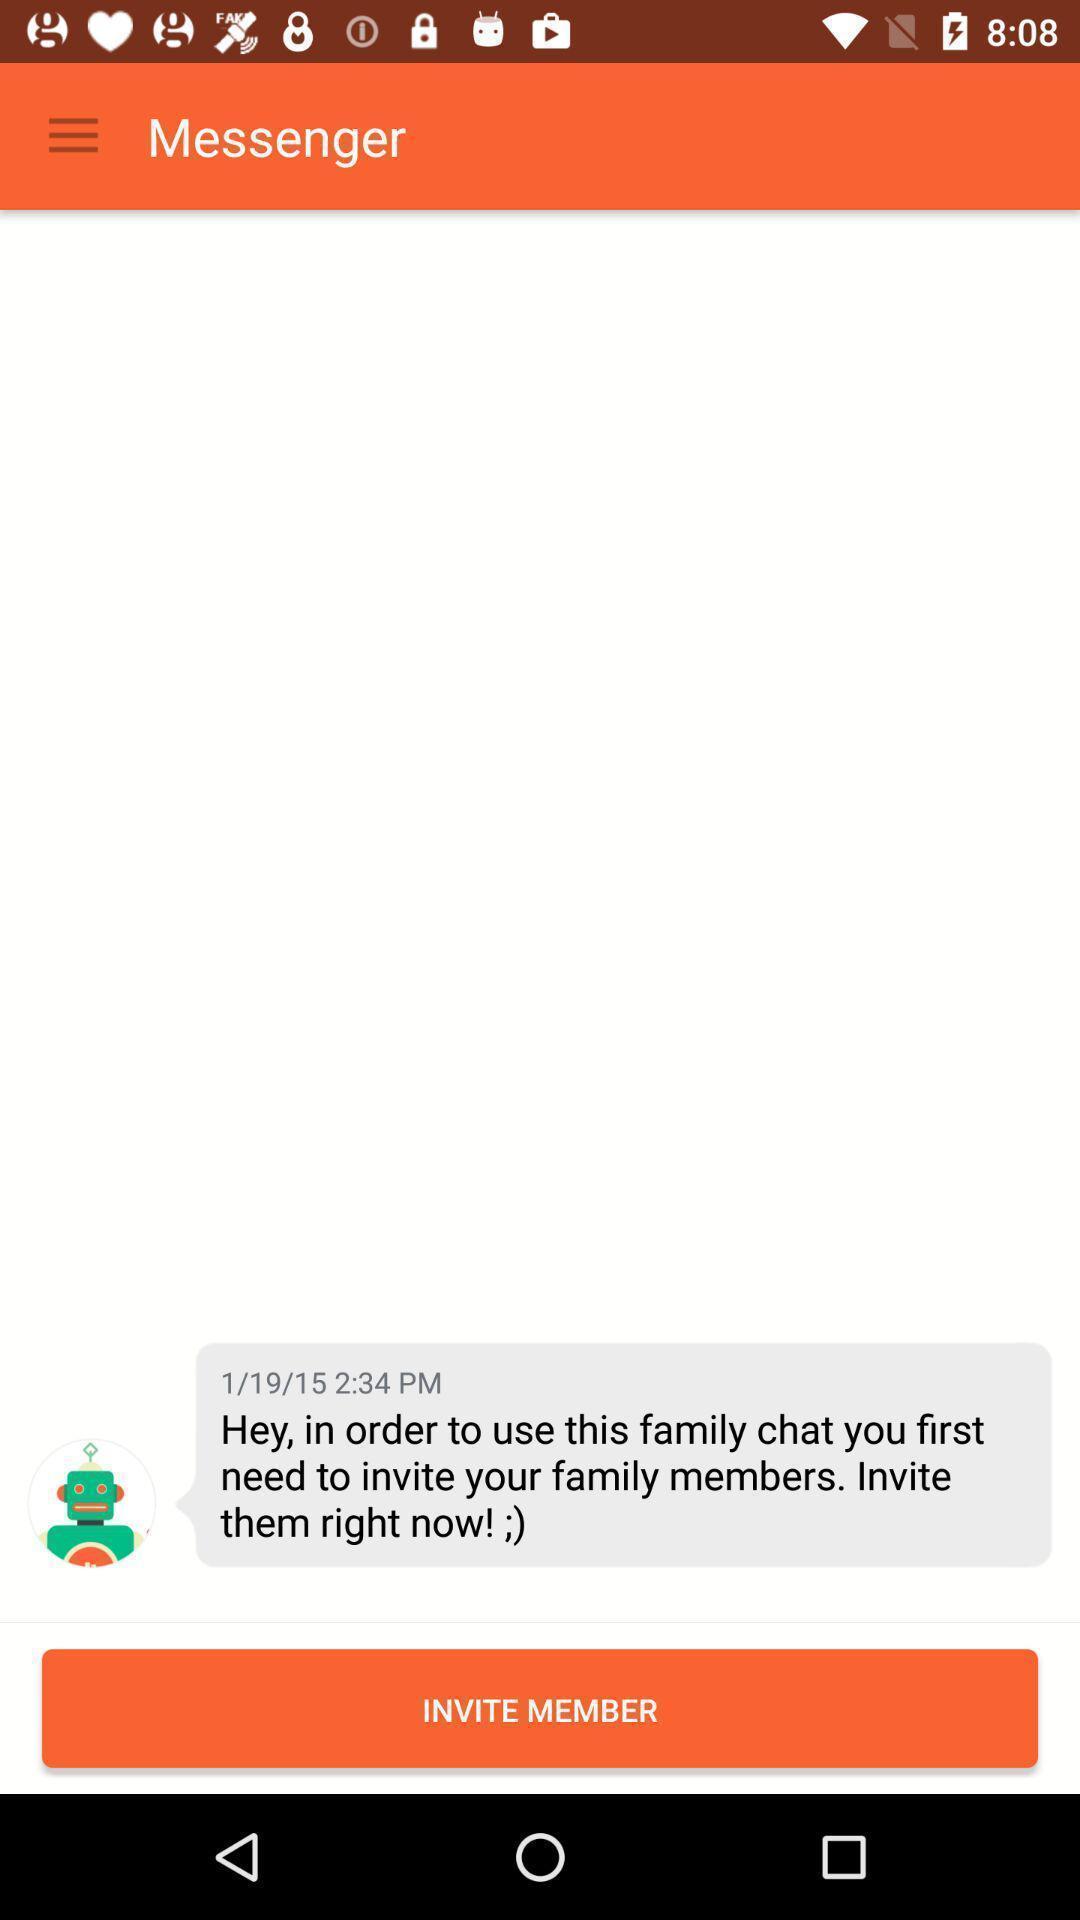Provide a textual representation of this image. Screen page of a social application. 